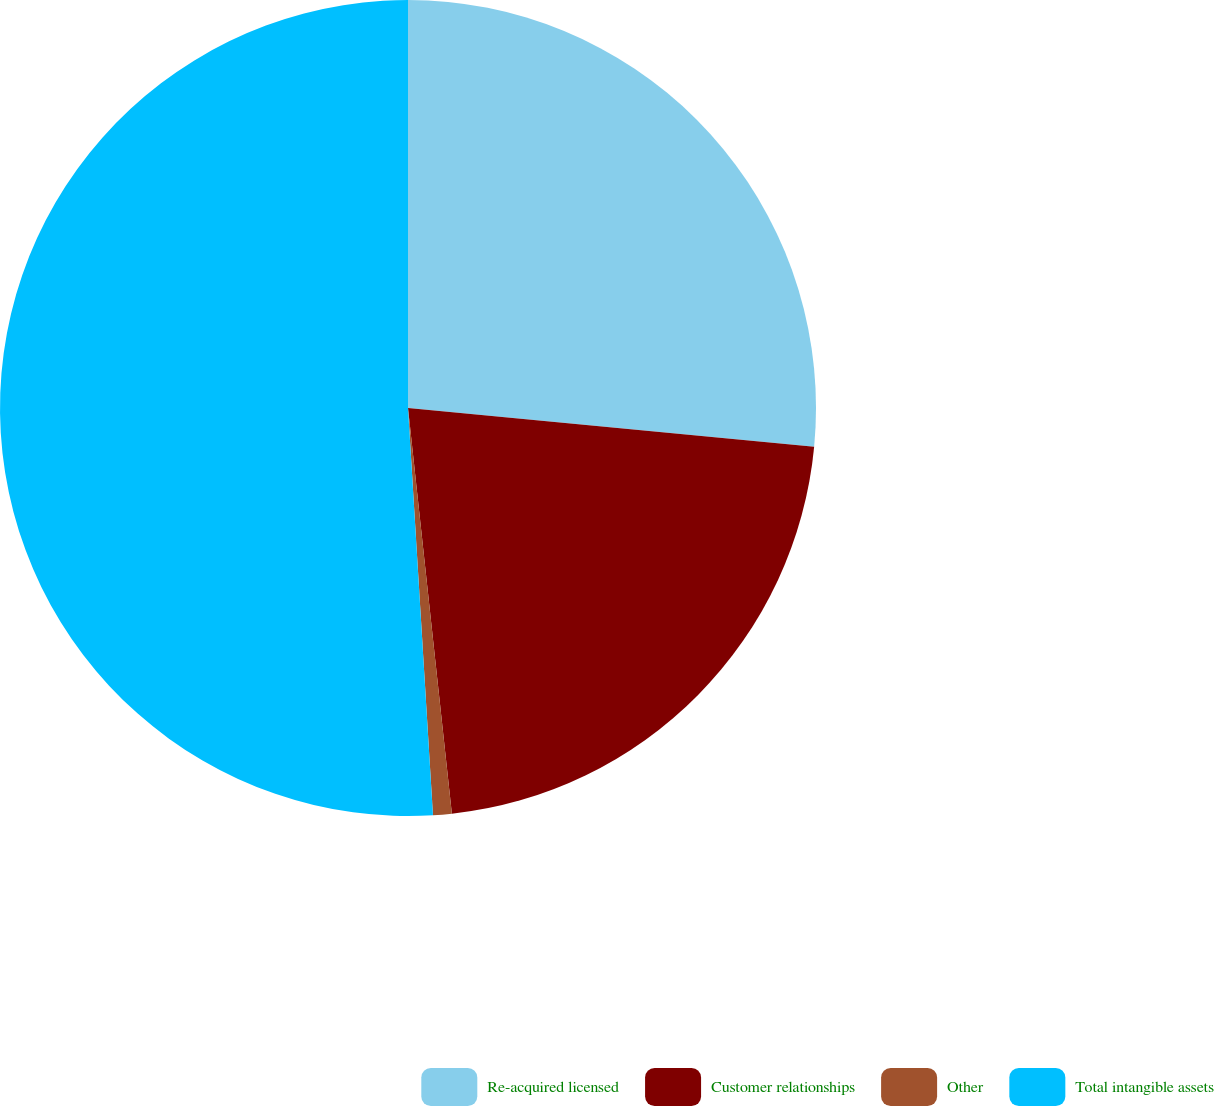Convert chart. <chart><loc_0><loc_0><loc_500><loc_500><pie_chart><fcel>Re-acquired licensed<fcel>Customer relationships<fcel>Other<fcel>Total intangible assets<nl><fcel>26.51%<fcel>21.77%<fcel>0.74%<fcel>50.97%<nl></chart> 